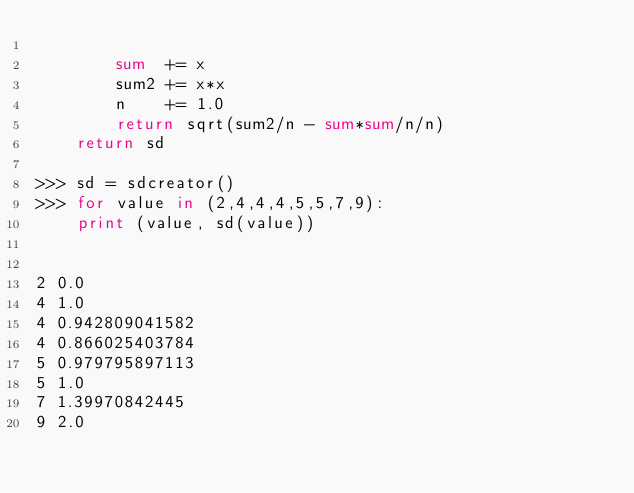<code> <loc_0><loc_0><loc_500><loc_500><_Python_>
		sum  += x
		sum2 += x*x
		n    += 1.0
		return sqrt(sum2/n - sum*sum/n/n)
	return sd

>>> sd = sdcreator()
>>> for value in (2,4,4,4,5,5,7,9):
	print (value, sd(value))

	
2 0.0
4 1.0
4 0.942809041582
4 0.866025403784
5 0.979795897113
5 1.0
7 1.39970842445
9 2.0
</code> 